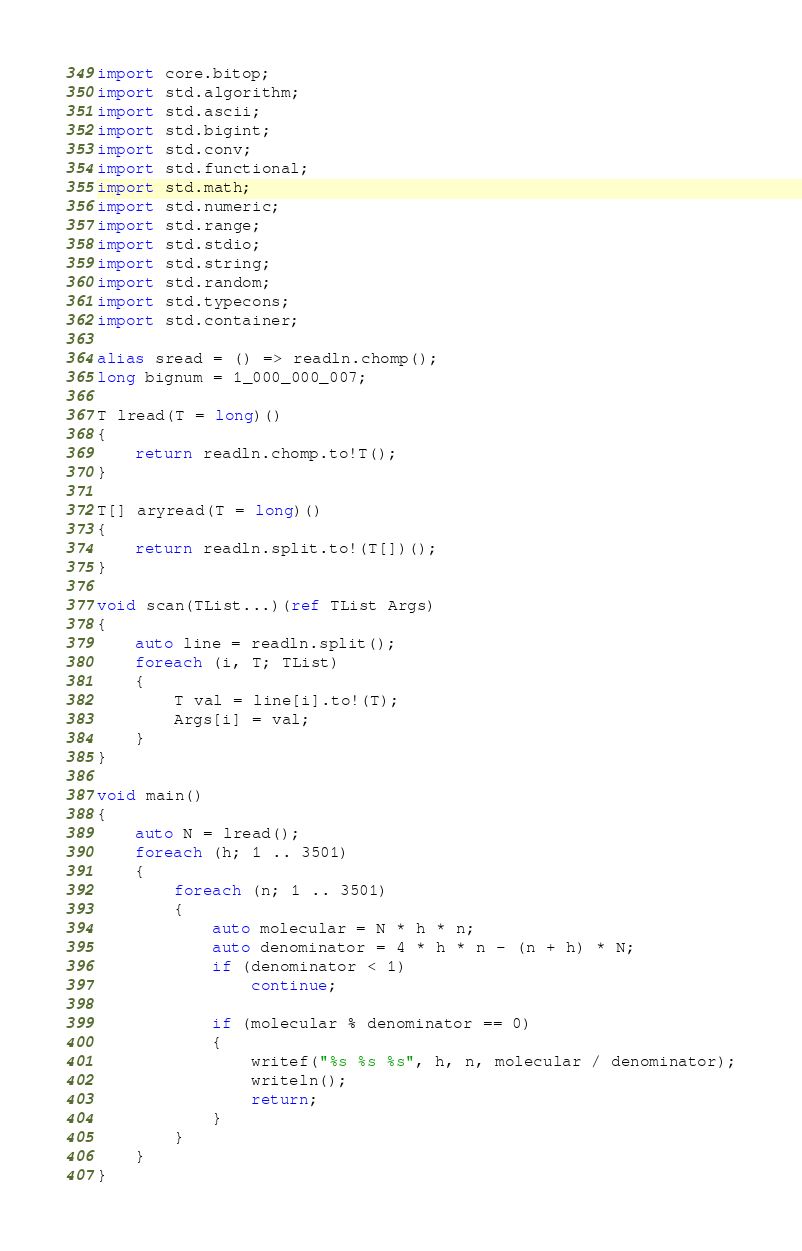<code> <loc_0><loc_0><loc_500><loc_500><_D_>import core.bitop;
import std.algorithm;
import std.ascii;
import std.bigint;
import std.conv;
import std.functional;
import std.math;
import std.numeric;
import std.range;
import std.stdio;
import std.string;
import std.random;
import std.typecons;
import std.container;

alias sread = () => readln.chomp();
long bignum = 1_000_000_007;

T lread(T = long)()
{
    return readln.chomp.to!T();
}

T[] aryread(T = long)()
{
    return readln.split.to!(T[])();
}

void scan(TList...)(ref TList Args)
{
    auto line = readln.split();
    foreach (i, T; TList)
    {
        T val = line[i].to!(T);
        Args[i] = val;
    }
}

void main()
{
    auto N = lread();
    foreach (h; 1 .. 3501)
    {
        foreach (n; 1 .. 3501)
        {
            auto molecular = N * h * n;
            auto denominator = 4 * h * n - (n + h) * N;
            if (denominator < 1)
                continue;

            if (molecular % denominator == 0)
            {
                writef("%s %s %s", h, n, molecular / denominator);
                writeln();
                return;
            }
        }
    }
}
</code> 